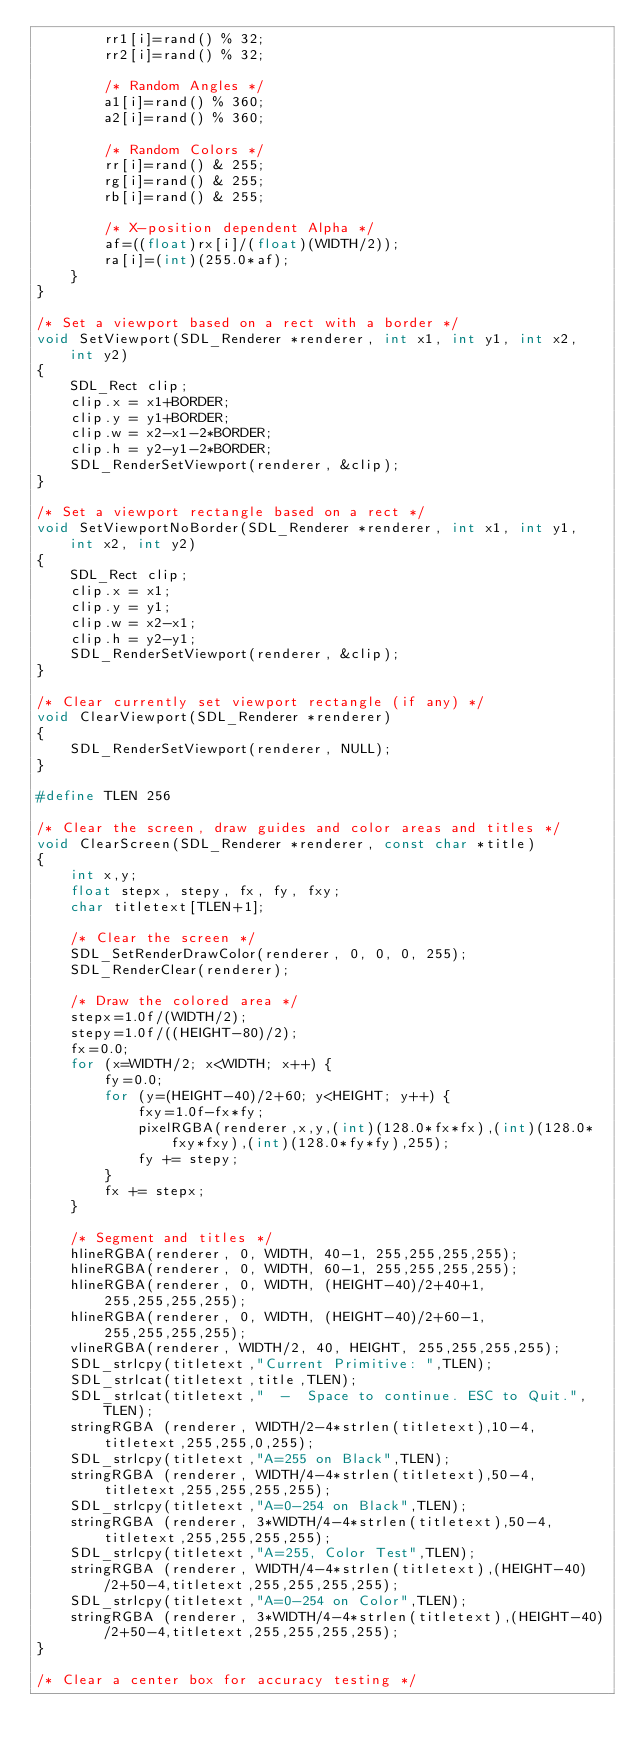Convert code to text. <code><loc_0><loc_0><loc_500><loc_500><_C_>		rr1[i]=rand() % 32;
		rr2[i]=rand() % 32;

		/* Random Angles */
		a1[i]=rand() % 360;
		a2[i]=rand() % 360;

		/* Random Colors */
		rr[i]=rand() & 255;
		rg[i]=rand() & 255;
		rb[i]=rand() & 255;

		/* X-position dependent Alpha */
		af=((float)rx[i]/(float)(WIDTH/2));
		ra[i]=(int)(255.0*af);
	} 
}

/* Set a viewport based on a rect with a border */
void SetViewport(SDL_Renderer *renderer, int x1, int y1, int x2, int y2)
{ 
	SDL_Rect clip;
	clip.x = x1+BORDER;
	clip.y = y1+BORDER;
	clip.w = x2-x1-2*BORDER;
	clip.h = y2-y1-2*BORDER;
	SDL_RenderSetViewport(renderer, &clip);
}

/* Set a viewport rectangle based on a rect */
void SetViewportNoBorder(SDL_Renderer *renderer, int x1, int y1, int x2, int y2)
{ 
	SDL_Rect clip;
	clip.x = x1;
	clip.y = y1;
	clip.w = x2-x1;
	clip.h = y2-y1;
	SDL_RenderSetViewport(renderer, &clip);
}

/* Clear currently set viewport rectangle (if any) */
void ClearViewport(SDL_Renderer *renderer)
{ 
	SDL_RenderSetViewport(renderer, NULL);
}

#define TLEN 256

/* Clear the screen, draw guides and color areas and titles */
void ClearScreen(SDL_Renderer *renderer, const char *title)
{
	int x,y;
	float stepx, stepy, fx, fy, fxy;
	char titletext[TLEN+1];

	/* Clear the screen */
    SDL_SetRenderDrawColor(renderer, 0, 0, 0, 255);
    SDL_RenderClear(renderer);

	/* Draw the colored area */
	stepx=1.0f/(WIDTH/2);
	stepy=1.0f/((HEIGHT-80)/2);
	fx=0.0;
	for (x=WIDTH/2; x<WIDTH; x++) {
		fy=0.0;
		for (y=(HEIGHT-40)/2+60; y<HEIGHT; y++) {
			fxy=1.0f-fx*fy;
			pixelRGBA(renderer,x,y,(int)(128.0*fx*fx),(int)(128.0*fxy*fxy),(int)(128.0*fy*fy),255);
			fy += stepy;
		}
		fx += stepx;
	}

	/* Segment and titles */
	hlineRGBA(renderer, 0, WIDTH, 40-1, 255,255,255,255);
	hlineRGBA(renderer, 0, WIDTH, 60-1, 255,255,255,255);
	hlineRGBA(renderer, 0, WIDTH, (HEIGHT-40)/2+40+1, 255,255,255,255); 
	hlineRGBA(renderer, 0, WIDTH, (HEIGHT-40)/2+60-1, 255,255,255,255); 
	vlineRGBA(renderer, WIDTH/2, 40, HEIGHT, 255,255,255,255);
	SDL_strlcpy(titletext,"Current Primitive: ",TLEN);
	SDL_strlcat(titletext,title,TLEN);
	SDL_strlcat(titletext,"  -  Space to continue. ESC to Quit.",TLEN);
	stringRGBA (renderer, WIDTH/2-4*strlen(titletext),10-4,titletext,255,255,0,255);
	SDL_strlcpy(titletext,"A=255 on Black",TLEN);
	stringRGBA (renderer, WIDTH/4-4*strlen(titletext),50-4,titletext,255,255,255,255);
	SDL_strlcpy(titletext,"A=0-254 on Black",TLEN);
	stringRGBA (renderer, 3*WIDTH/4-4*strlen(titletext),50-4,titletext,255,255,255,255);
	SDL_strlcpy(titletext,"A=255, Color Test",TLEN);
	stringRGBA (renderer, WIDTH/4-4*strlen(titletext),(HEIGHT-40)/2+50-4,titletext,255,255,255,255);
	SDL_strlcpy(titletext,"A=0-254 on Color",TLEN);
	stringRGBA (renderer, 3*WIDTH/4-4*strlen(titletext),(HEIGHT-40)/2+50-4,titletext,255,255,255,255);
}

/* Clear a center box for accuracy testing */</code> 